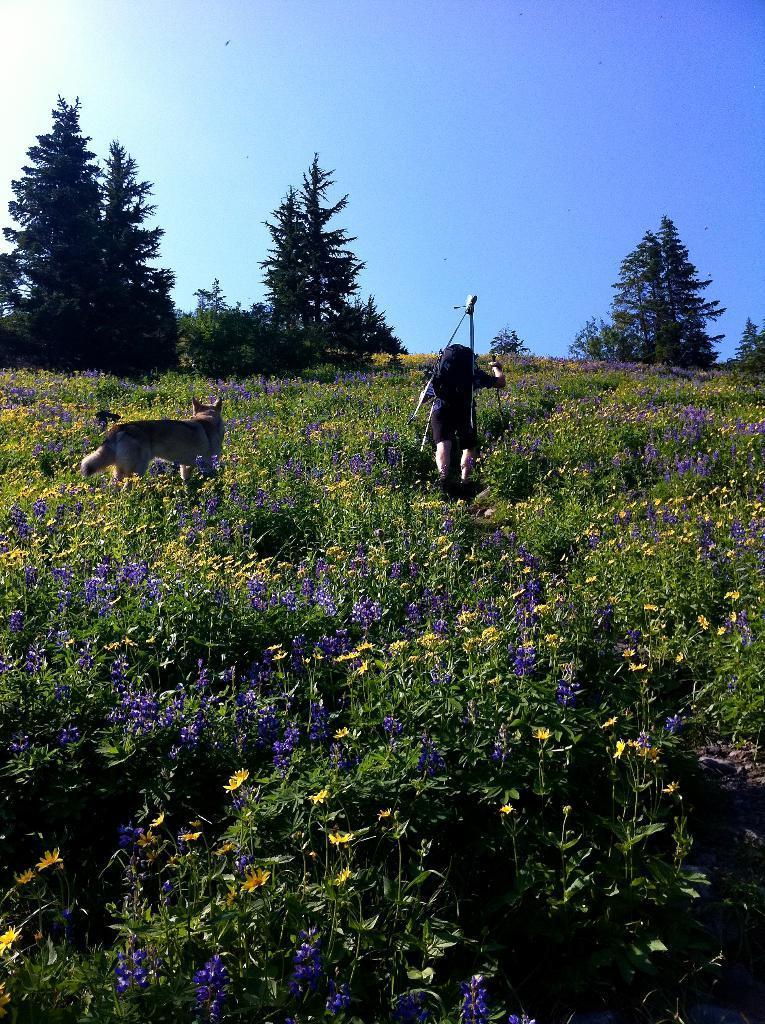Describe this image in one or two sentences. In this image we can see a dog and a person on the ground, there are some trees and plants with flowers, in the background, we can see the sky. 